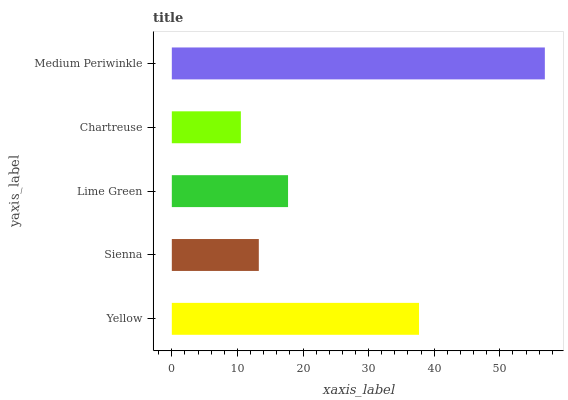Is Chartreuse the minimum?
Answer yes or no. Yes. Is Medium Periwinkle the maximum?
Answer yes or no. Yes. Is Sienna the minimum?
Answer yes or no. No. Is Sienna the maximum?
Answer yes or no. No. Is Yellow greater than Sienna?
Answer yes or no. Yes. Is Sienna less than Yellow?
Answer yes or no. Yes. Is Sienna greater than Yellow?
Answer yes or no. No. Is Yellow less than Sienna?
Answer yes or no. No. Is Lime Green the high median?
Answer yes or no. Yes. Is Lime Green the low median?
Answer yes or no. Yes. Is Sienna the high median?
Answer yes or no. No. Is Medium Periwinkle the low median?
Answer yes or no. No. 